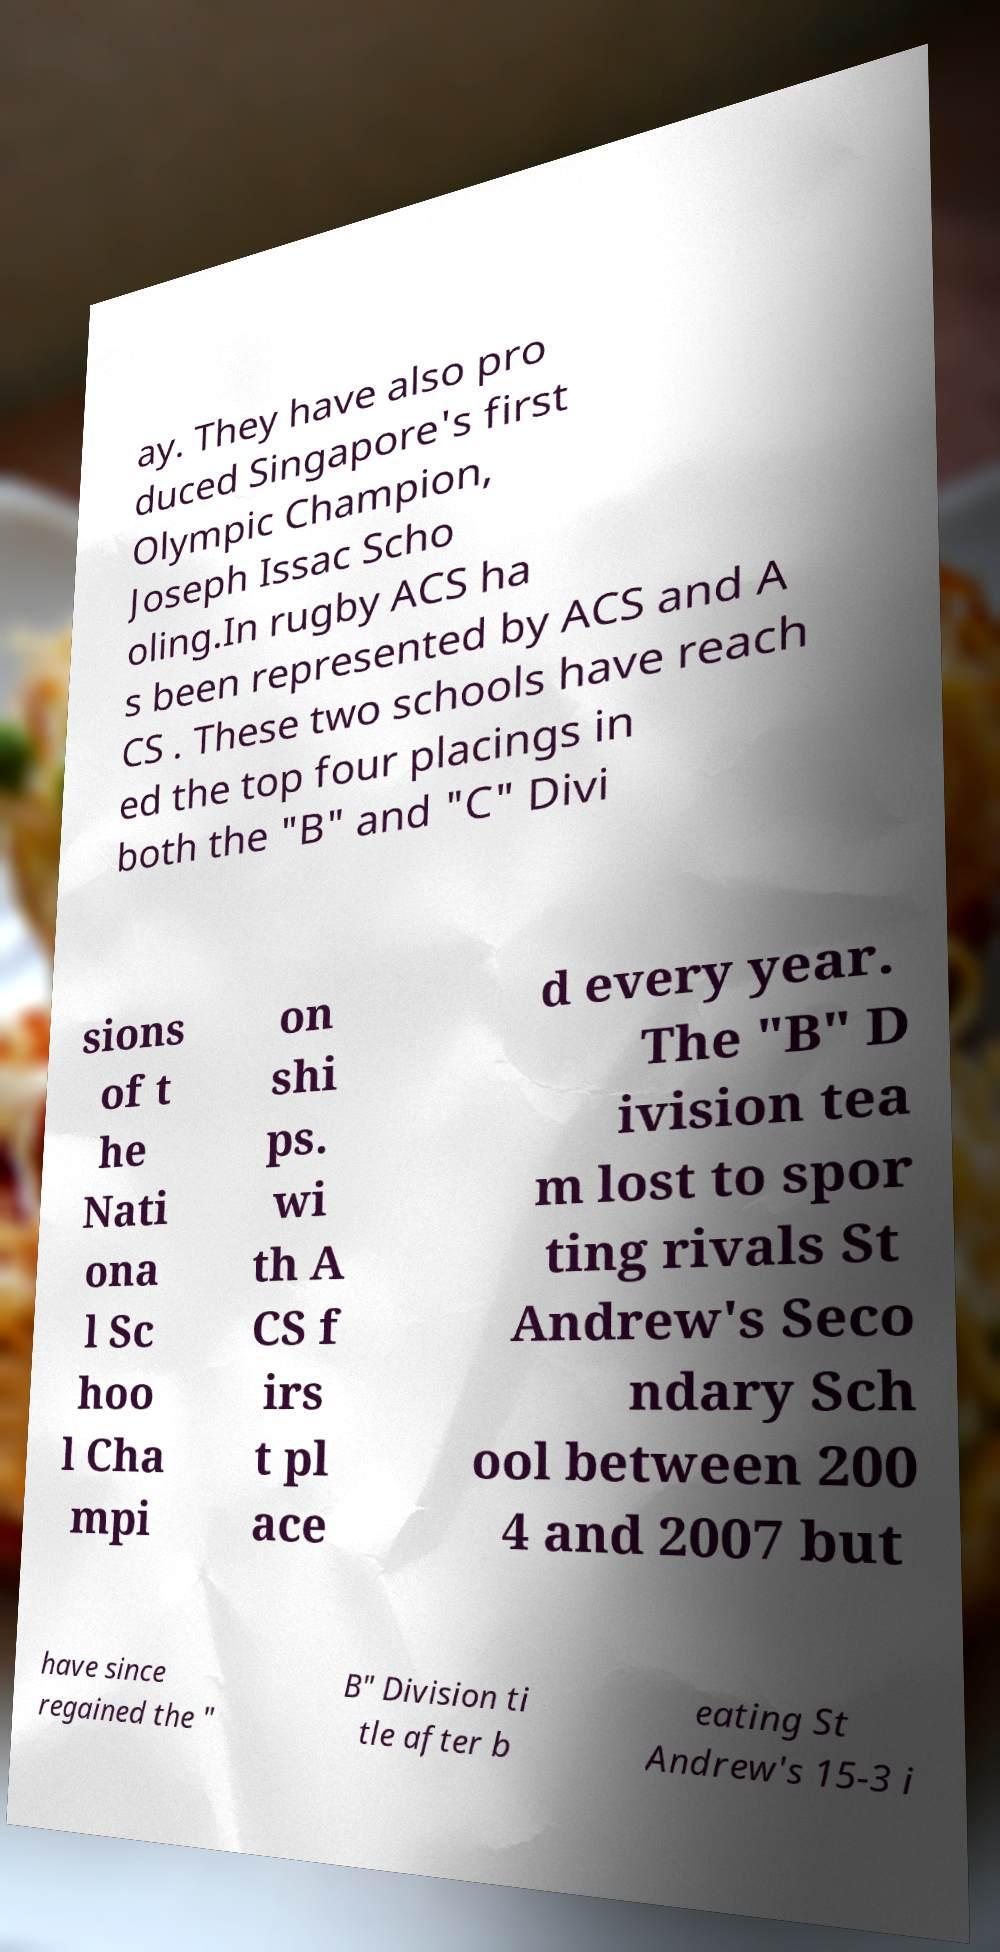For documentation purposes, I need the text within this image transcribed. Could you provide that? ay. They have also pro duced Singapore's first Olympic Champion, Joseph Issac Scho oling.In rugby ACS ha s been represented by ACS and A CS . These two schools have reach ed the top four placings in both the "B" and "C" Divi sions of t he Nati ona l Sc hoo l Cha mpi on shi ps. wi th A CS f irs t pl ace d every year. The "B" D ivision tea m lost to spor ting rivals St Andrew's Seco ndary Sch ool between 200 4 and 2007 but have since regained the " B" Division ti tle after b eating St Andrew's 15-3 i 